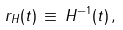<formula> <loc_0><loc_0><loc_500><loc_500>r _ { H } ( t ) \, \equiv \, H ^ { - 1 } ( t ) \, ,</formula> 